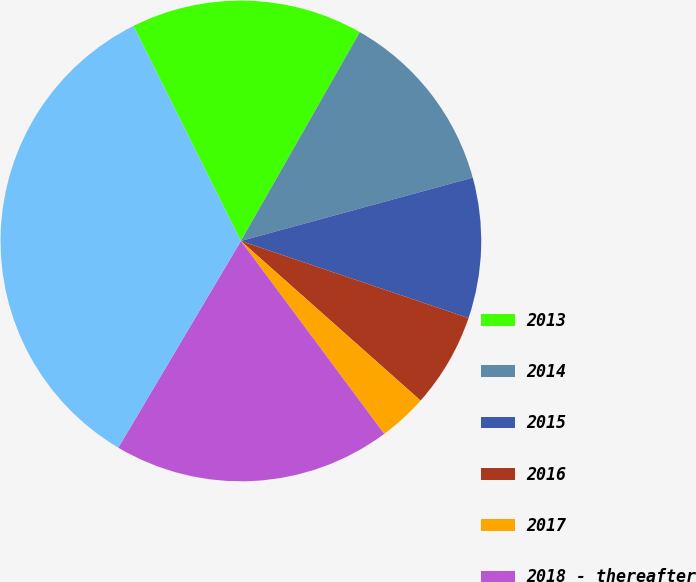<chart> <loc_0><loc_0><loc_500><loc_500><pie_chart><fcel>2013<fcel>2014<fcel>2015<fcel>2016<fcel>2017<fcel>2018 - thereafter<fcel>Total<nl><fcel>15.61%<fcel>12.52%<fcel>9.44%<fcel>6.36%<fcel>3.27%<fcel>18.69%<fcel>34.11%<nl></chart> 